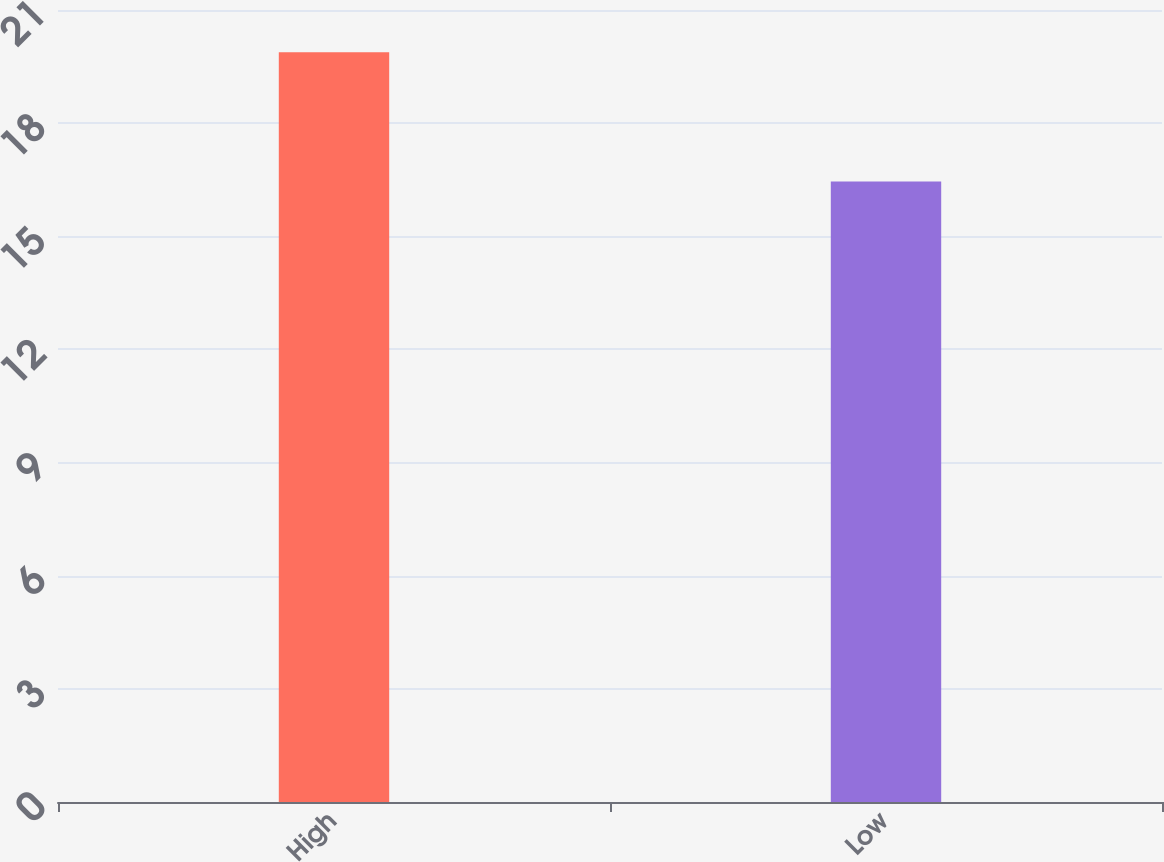Convert chart. <chart><loc_0><loc_0><loc_500><loc_500><bar_chart><fcel>High<fcel>Low<nl><fcel>19.88<fcel>16.45<nl></chart> 